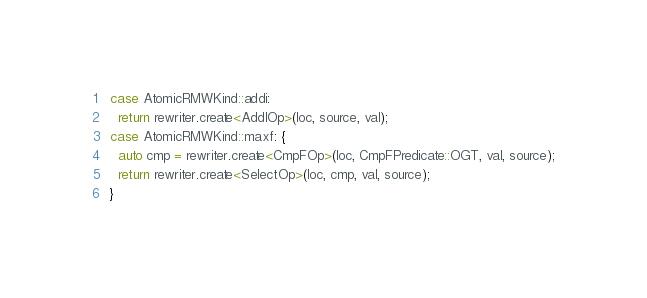<code> <loc_0><loc_0><loc_500><loc_500><_C++_>  case AtomicRMWKind::addi:
    return rewriter.create<AddIOp>(loc, source, val);
  case AtomicRMWKind::maxf: {
    auto cmp = rewriter.create<CmpFOp>(loc, CmpFPredicate::OGT, val, source);
    return rewriter.create<SelectOp>(loc, cmp, val, source);
  }</code> 